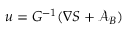<formula> <loc_0><loc_0><loc_500><loc_500>u = G ^ { - 1 } ( \nabla S + { \mathcal { A } } _ { B } )</formula> 